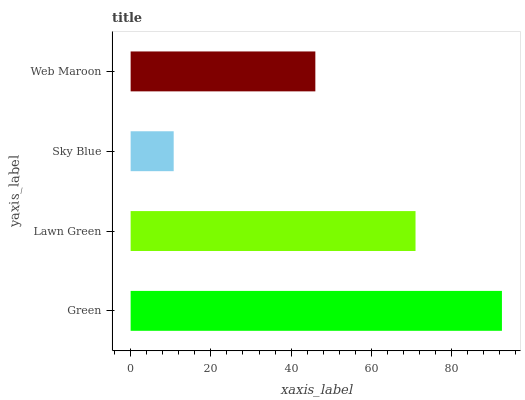Is Sky Blue the minimum?
Answer yes or no. Yes. Is Green the maximum?
Answer yes or no. Yes. Is Lawn Green the minimum?
Answer yes or no. No. Is Lawn Green the maximum?
Answer yes or no. No. Is Green greater than Lawn Green?
Answer yes or no. Yes. Is Lawn Green less than Green?
Answer yes or no. Yes. Is Lawn Green greater than Green?
Answer yes or no. No. Is Green less than Lawn Green?
Answer yes or no. No. Is Lawn Green the high median?
Answer yes or no. Yes. Is Web Maroon the low median?
Answer yes or no. Yes. Is Sky Blue the high median?
Answer yes or no. No. Is Sky Blue the low median?
Answer yes or no. No. 